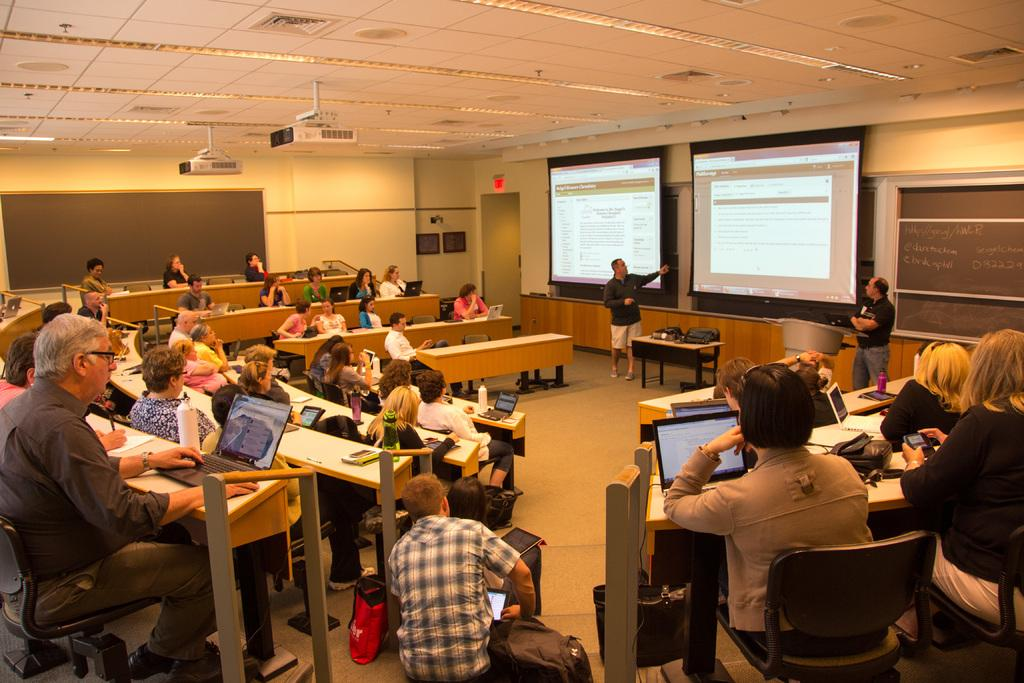What are the people in the image doing? There is a group of persons sitting on a bench in the image. Can you describe the person in the middle of the image? There is a person in the middle of the image explaining something. What objects are visible at the top of the image? There are projectors visible at the top of the image. What type of hose is being used by the person in the image? There is no hose present in the image. Can you describe the fowl that is sitting on the bench with the group of persons? There are no fowl present in the image; it features a group of persons sitting on a bench. 